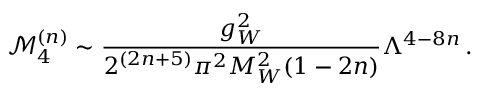<formula> <loc_0><loc_0><loc_500><loc_500>\mathcal { M } _ { 4 } ^ { ( n ) } \sim \frac { g _ { W } ^ { 2 } } { 2 ^ { ( 2 n + 5 ) } \pi ^ { 2 } M _ { W } ^ { 2 } ( 1 - 2 n ) } \Lambda ^ { 4 - 8 n } \, .</formula> 